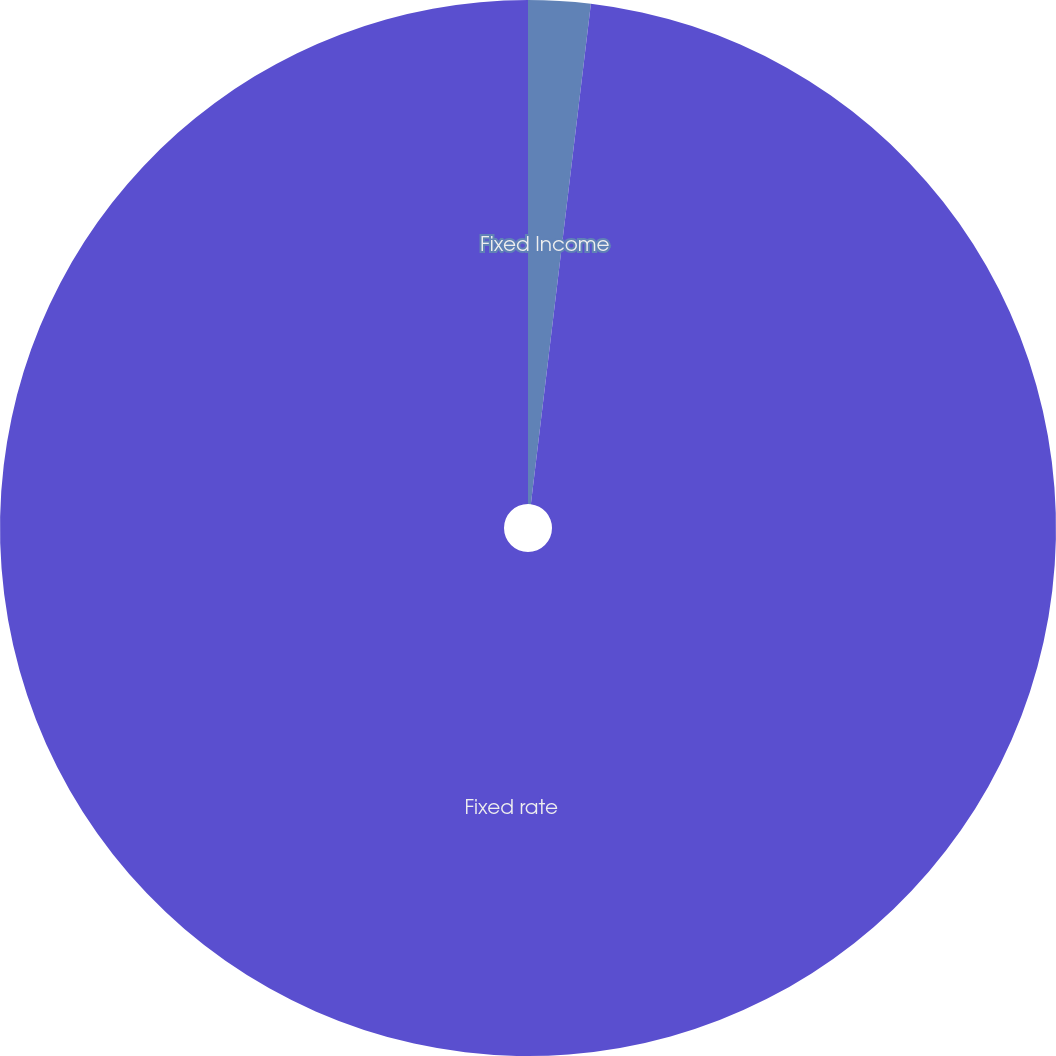Convert chart. <chart><loc_0><loc_0><loc_500><loc_500><pie_chart><fcel>Fixed Income<fcel>Fixed rate<nl><fcel>1.9%<fcel>98.1%<nl></chart> 